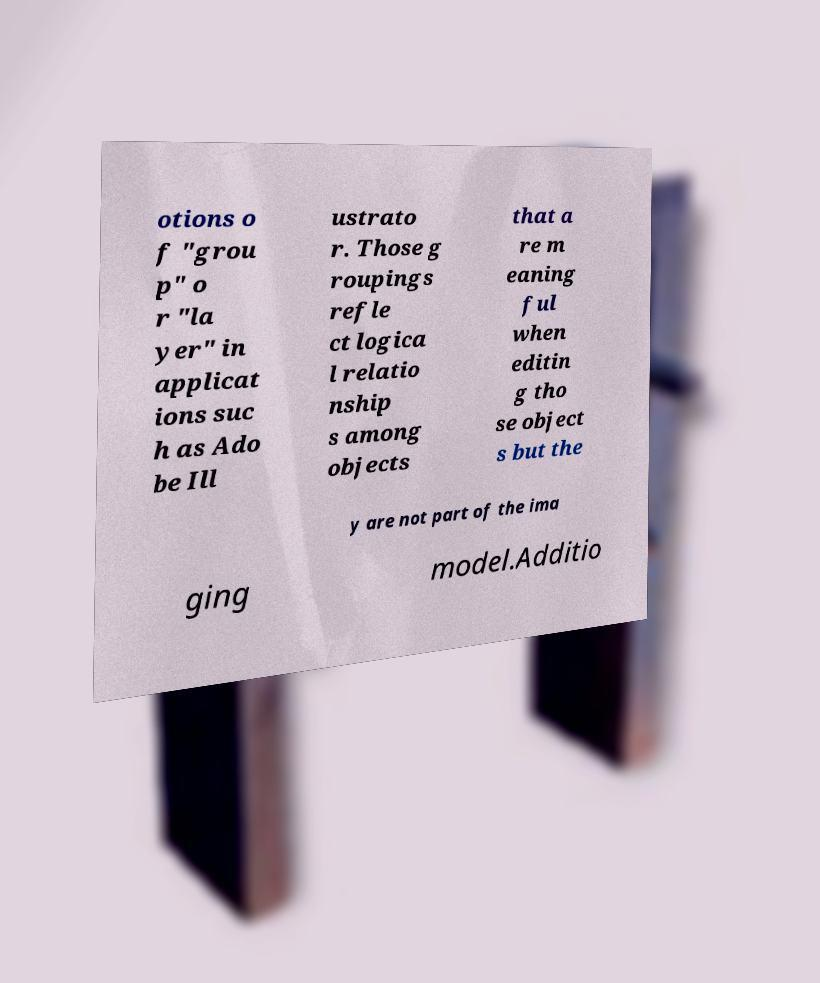Can you accurately transcribe the text from the provided image for me? otions o f "grou p" o r "la yer" in applicat ions suc h as Ado be Ill ustrato r. Those g roupings refle ct logica l relatio nship s among objects that a re m eaning ful when editin g tho se object s but the y are not part of the ima ging model.Additio 